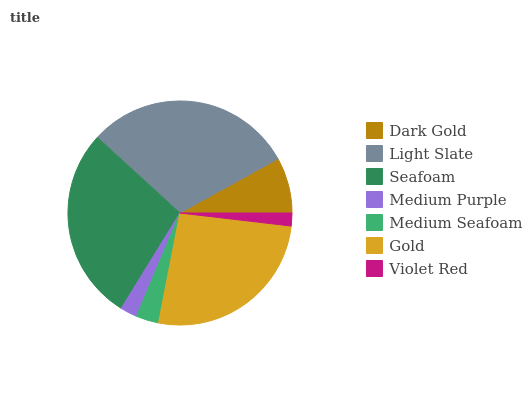Is Violet Red the minimum?
Answer yes or no. Yes. Is Light Slate the maximum?
Answer yes or no. Yes. Is Seafoam the minimum?
Answer yes or no. No. Is Seafoam the maximum?
Answer yes or no. No. Is Light Slate greater than Seafoam?
Answer yes or no. Yes. Is Seafoam less than Light Slate?
Answer yes or no. Yes. Is Seafoam greater than Light Slate?
Answer yes or no. No. Is Light Slate less than Seafoam?
Answer yes or no. No. Is Dark Gold the high median?
Answer yes or no. Yes. Is Dark Gold the low median?
Answer yes or no. Yes. Is Violet Red the high median?
Answer yes or no. No. Is Seafoam the low median?
Answer yes or no. No. 